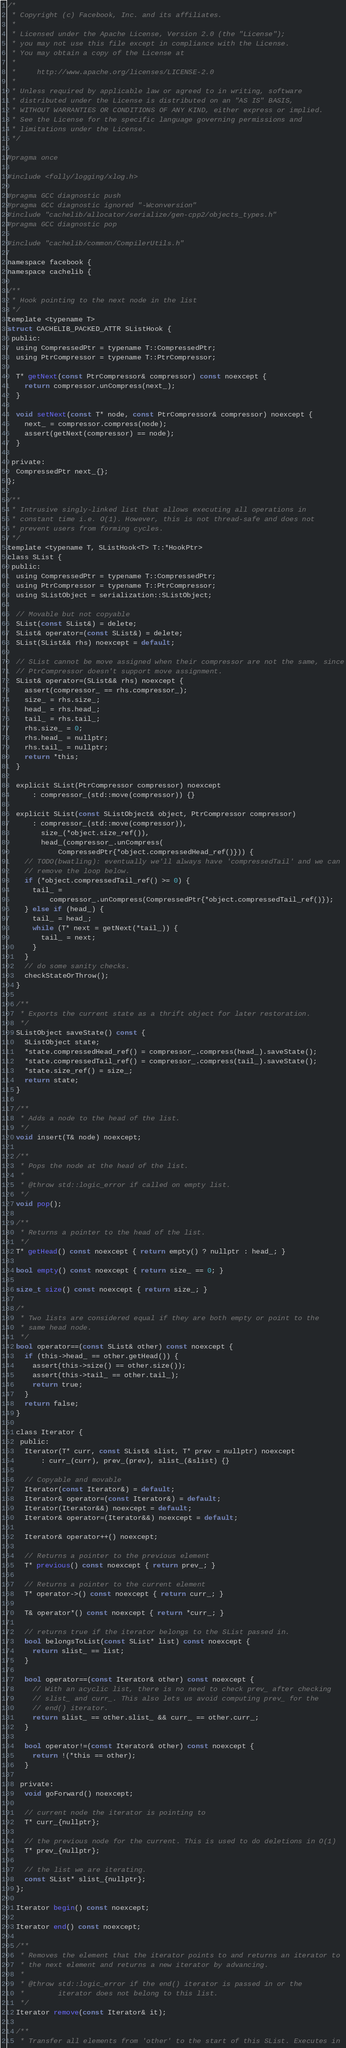<code> <loc_0><loc_0><loc_500><loc_500><_C_>/*
 * Copyright (c) Facebook, Inc. and its affiliates.
 *
 * Licensed under the Apache License, Version 2.0 (the "License");
 * you may not use this file except in compliance with the License.
 * You may obtain a copy of the License at
 *
 *     http://www.apache.org/licenses/LICENSE-2.0
 *
 * Unless required by applicable law or agreed to in writing, software
 * distributed under the License is distributed on an "AS IS" BASIS,
 * WITHOUT WARRANTIES OR CONDITIONS OF ANY KIND, either express or implied.
 * See the License for the specific language governing permissions and
 * limitations under the License.
 */

#pragma once

#include <folly/logging/xlog.h>

#pragma GCC diagnostic push
#pragma GCC diagnostic ignored "-Wconversion"
#include "cachelib/allocator/serialize/gen-cpp2/objects_types.h"
#pragma GCC diagnostic pop

#include "cachelib/common/CompilerUtils.h"

namespace facebook {
namespace cachelib {

/**
 * Hook pointing to the next node in the list
 */
template <typename T>
struct CACHELIB_PACKED_ATTR SListHook {
 public:
  using CompressedPtr = typename T::CompressedPtr;
  using PtrCompressor = typename T::PtrCompressor;

  T* getNext(const PtrCompressor& compressor) const noexcept {
    return compressor.unCompress(next_);
  }

  void setNext(const T* node, const PtrCompressor& compressor) noexcept {
    next_ = compressor.compress(node);
    assert(getNext(compressor) == node);
  }

 private:
  CompressedPtr next_{};
};

/**
 * Intrusive singly-linked list that allows executing all operations in
 * constant time i.e. O(1). However, this is not thread-safe and does not
 * prevent users from forming cycles.
 */
template <typename T, SListHook<T> T::*HookPtr>
class SList {
 public:
  using CompressedPtr = typename T::CompressedPtr;
  using PtrCompressor = typename T::PtrCompressor;
  using SListObject = serialization::SListObject;

  // Movable but not copyable
  SList(const SList&) = delete;
  SList& operator=(const SList&) = delete;
  SList(SList&& rhs) noexcept = default;

  // SList cannot be move assigned when their compressor are not the same, since
  // PtrCompressor doesn't support move assignment.
  SList& operator=(SList&& rhs) noexcept {
    assert(compressor_ == rhs.compressor_);
    size_ = rhs.size_;
    head_ = rhs.head_;
    tail_ = rhs.tail_;
    rhs.size_ = 0;
    rhs.head_ = nullptr;
    rhs.tail_ = nullptr;
    return *this;
  }

  explicit SList(PtrCompressor compressor) noexcept
      : compressor_(std::move(compressor)) {}

  explicit SList(const SListObject& object, PtrCompressor compressor)
      : compressor_(std::move(compressor)),
        size_(*object.size_ref()),
        head_(compressor_.unCompress(
            CompressedPtr{*object.compressedHead_ref()})) {
    // TODO(bwatling): eventually we'll always have 'compressedTail' and we can
    // remove the loop below.
    if (*object.compressedTail_ref() >= 0) {
      tail_ =
          compressor_.unCompress(CompressedPtr{*object.compressedTail_ref()});
    } else if (head_) {
      tail_ = head_;
      while (T* next = getNext(*tail_)) {
        tail_ = next;
      }
    }
    // do some sanity checks.
    checkStateOrThrow();
  }

  /**
   * Exports the current state as a thrift object for later restoration.
   */
  SListObject saveState() const {
    SListObject state;
    *state.compressedHead_ref() = compressor_.compress(head_).saveState();
    *state.compressedTail_ref() = compressor_.compress(tail_).saveState();
    *state.size_ref() = size_;
    return state;
  }

  /**
   * Adds a node to the head of the list.
   */
  void insert(T& node) noexcept;

  /**
   * Pops the node at the head of the list.
   *
   * @throw std::logic_error if called on empty list.
   */
  void pop();

  /**
   * Returns a pointer to the head of the list.
   */
  T* getHead() const noexcept { return empty() ? nullptr : head_; }

  bool empty() const noexcept { return size_ == 0; }

  size_t size() const noexcept { return size_; }

  /*
   * Two lists are considered equal if they are both empty or point to the
   * same head node.
   */
  bool operator==(const SList& other) const noexcept {
    if (this->head_ == other.getHead()) {
      assert(this->size() == other.size());
      assert(this->tail_ == other.tail_);
      return true;
    }
    return false;
  }

  class Iterator {
   public:
    Iterator(T* curr, const SList& slist, T* prev = nullptr) noexcept
        : curr_(curr), prev_(prev), slist_(&slist) {}

    // Copyable and movable
    Iterator(const Iterator&) = default;
    Iterator& operator=(const Iterator&) = default;
    Iterator(Iterator&&) noexcept = default;
    Iterator& operator=(Iterator&&) noexcept = default;

    Iterator& operator++() noexcept;

    // Returns a pointer to the previous element
    T* previous() const noexcept { return prev_; }

    // Returns a pointer to the current element
    T* operator->() const noexcept { return curr_; }

    T& operator*() const noexcept { return *curr_; }

    // returns true if the iterator belongs to the SList passed in.
    bool belongsToList(const SList* list) const noexcept {
      return slist_ == list;
    }

    bool operator==(const Iterator& other) const noexcept {
      // With an acyclic list, there is no need to check prev_ after checking
      // slist_ and curr_. This also lets us avoid computing prev_ for the
      // end() iterator.
      return slist_ == other.slist_ && curr_ == other.curr_;
    }

    bool operator!=(const Iterator& other) const noexcept {
      return !(*this == other);
    }

   private:
    void goForward() noexcept;

    // current node the iterator is pointing to
    T* curr_{nullptr};

    // the previous node for the current. This is used to do deletions in O(1)
    T* prev_{nullptr};

    // the list we are iterating.
    const SList* slist_{nullptr};
  };

  Iterator begin() const noexcept;

  Iterator end() const noexcept;

  /**
   * Removes the element that the iterator points to and returns an iterator to
   * the next element and returns a new iterator by advancing.
   *
   * @throw std::logic_error if the end() iterator is passed in or the
   *        iterator does not belong to this list.
   */
  Iterator remove(const Iterator& it);

  /**
   * Transfer all elements from 'other' to the start of this SList. Executes in</code> 